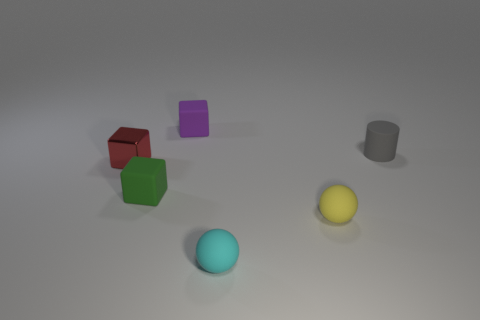Are there fewer tiny things that are behind the tiny cyan sphere than tiny cyan objects that are behind the tiny matte cylinder?
Keep it short and to the point. No. There is a yellow sphere that is the same size as the green cube; what is it made of?
Make the answer very short. Rubber. What shape is the gray matte object on the right side of the matte cube in front of the purple cube right of the red shiny block?
Your answer should be compact. Cylinder. What is the size of the cube that is behind the red block?
Make the answer very short. Small. What shape is the red metallic thing that is the same size as the cyan matte object?
Your response must be concise. Cube. How many things are either small red metal blocks or small rubber objects to the left of the yellow rubber thing?
Ensure brevity in your answer.  4. What number of small rubber balls are in front of the rubber sphere right of the small sphere that is in front of the small yellow rubber object?
Keep it short and to the point. 1. What color is the other sphere that is the same material as the small cyan ball?
Your answer should be very brief. Yellow. There is a matte object that is behind the cylinder; is it the same size as the green block?
Your answer should be very brief. Yes. What number of objects are purple things or tiny shiny objects?
Offer a terse response. 2. 